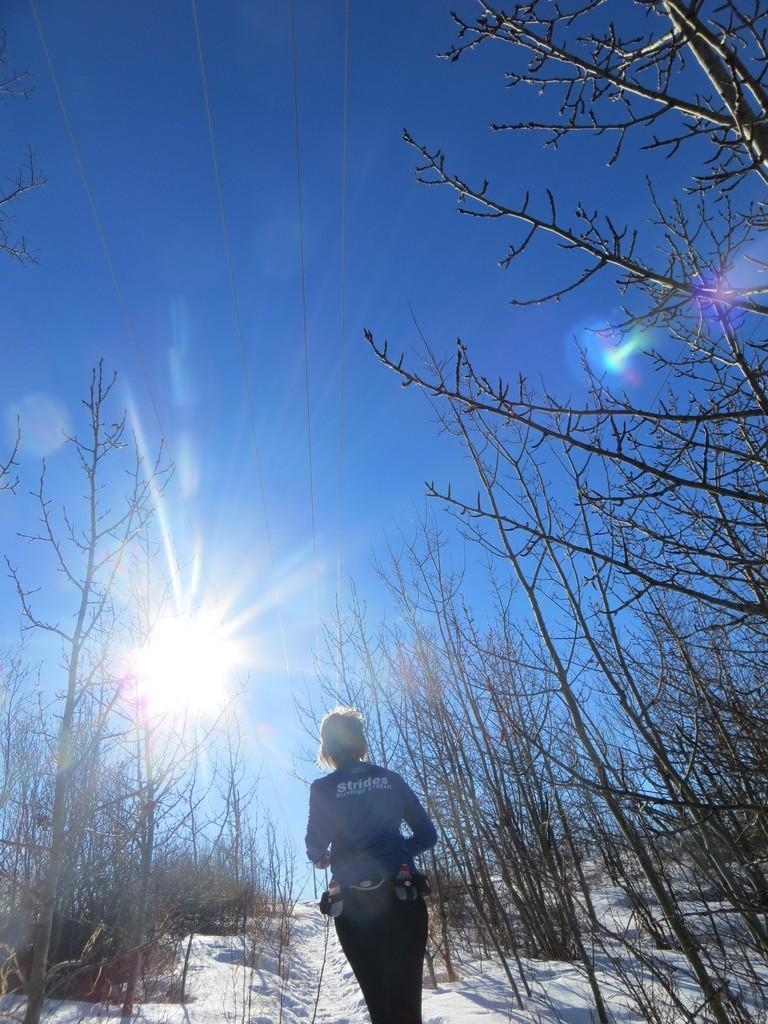Please provide a concise description of this image. In the image there is a person walking on the snow with dry trees on either side and above its sky with clouds. 